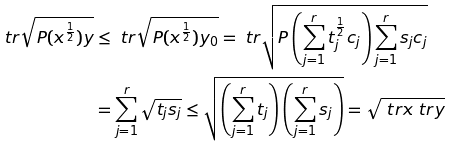Convert formula to latex. <formula><loc_0><loc_0><loc_500><loc_500>\ t r \sqrt { P ( x ^ { \frac { 1 } { 2 } } ) y } & \leq \ t r \sqrt { P ( x ^ { \frac { 1 } { 2 } } ) y _ { 0 } } = \ t r \sqrt { P \left ( \sum _ { j = 1 } ^ { r } t _ { j } ^ { \frac { 1 } { 2 } } c _ { j } \right ) \sum _ { j = 1 } ^ { r } s _ { j } c _ { j } } \\ & = \sum _ { j = 1 } ^ { r } \sqrt { t _ { j } s _ { j } } \leq \sqrt { \left ( \sum _ { j = 1 } ^ { r } t _ { j } \right ) \left ( \sum _ { j = 1 } ^ { r } s _ { j } \right ) } = \sqrt { \ t r x \ t r y }</formula> 